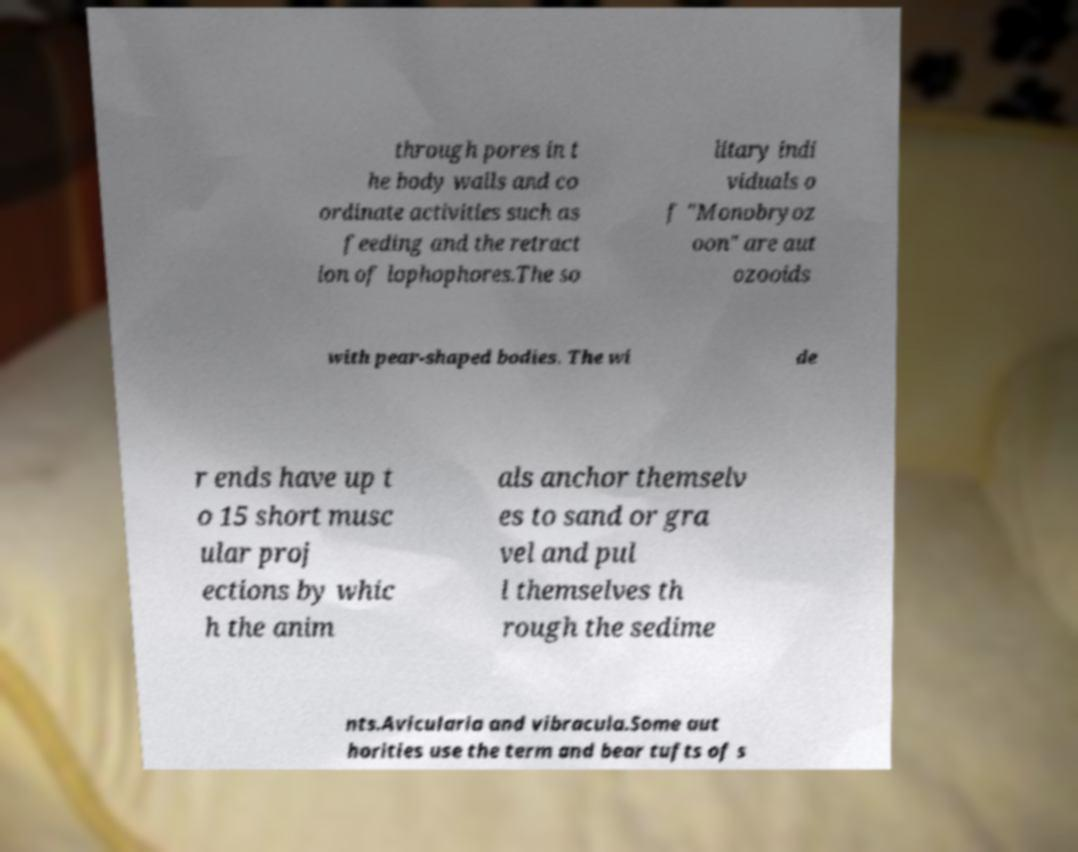Please identify and transcribe the text found in this image. through pores in t he body walls and co ordinate activities such as feeding and the retract ion of lophophores.The so litary indi viduals o f "Monobryoz oon" are aut ozooids with pear-shaped bodies. The wi de r ends have up t o 15 short musc ular proj ections by whic h the anim als anchor themselv es to sand or gra vel and pul l themselves th rough the sedime nts.Avicularia and vibracula.Some aut horities use the term and bear tufts of s 